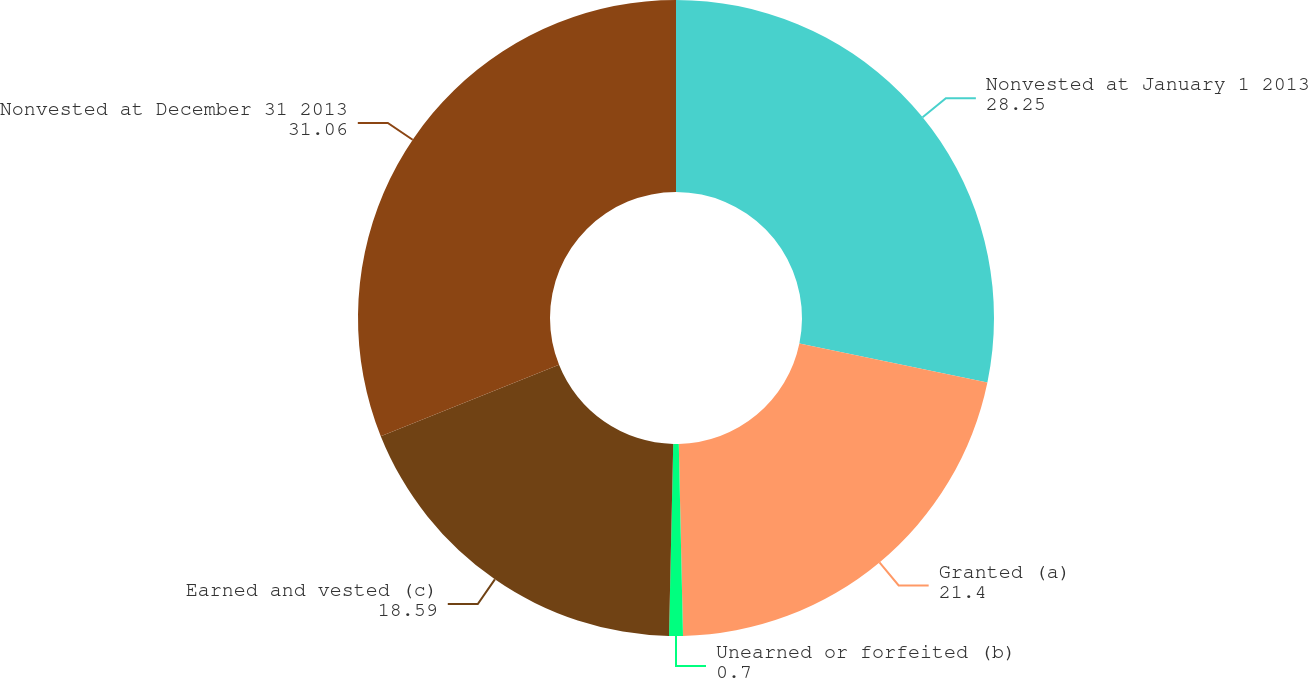Convert chart to OTSL. <chart><loc_0><loc_0><loc_500><loc_500><pie_chart><fcel>Nonvested at January 1 2013<fcel>Granted (a)<fcel>Unearned or forfeited (b)<fcel>Earned and vested (c)<fcel>Nonvested at December 31 2013<nl><fcel>28.25%<fcel>21.4%<fcel>0.7%<fcel>18.59%<fcel>31.06%<nl></chart> 